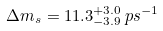Convert formula to latex. <formula><loc_0><loc_0><loc_500><loc_500>\Delta m _ { s } = 1 1 . 3 _ { - 3 . 9 } ^ { + 3 . 0 } \, p s ^ { - 1 } \\</formula> 